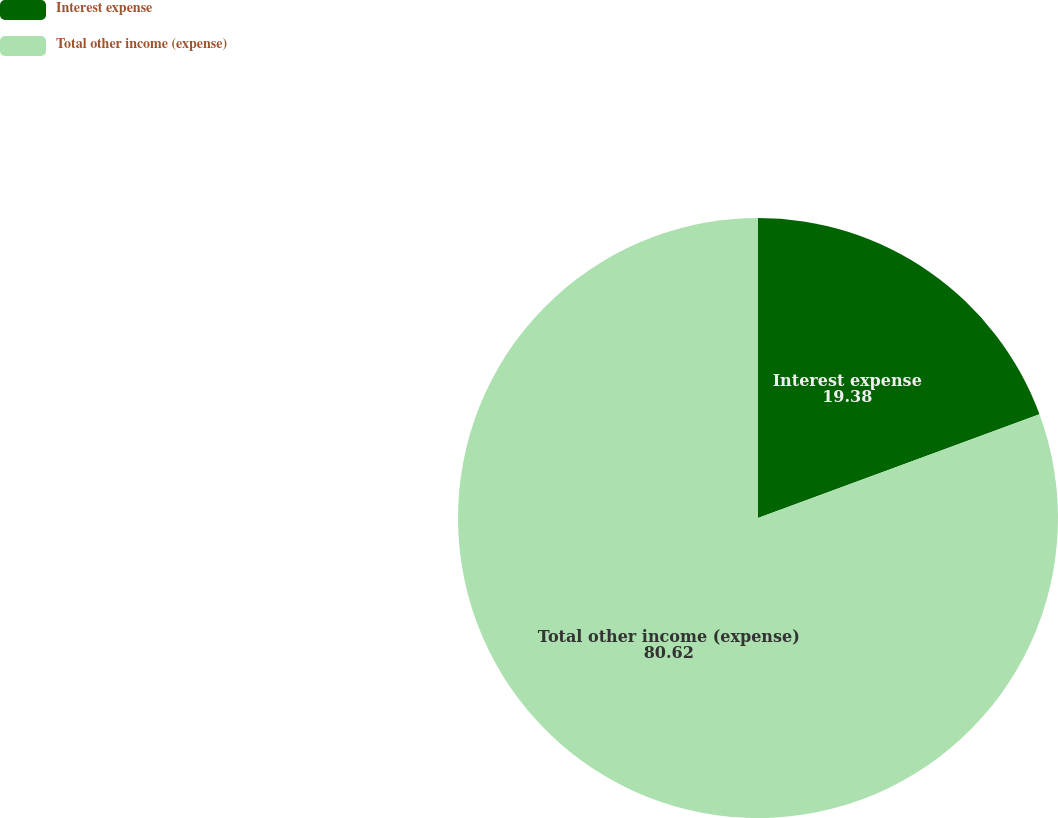Convert chart to OTSL. <chart><loc_0><loc_0><loc_500><loc_500><pie_chart><fcel>Interest expense<fcel>Total other income (expense)<nl><fcel>19.38%<fcel>80.62%<nl></chart> 